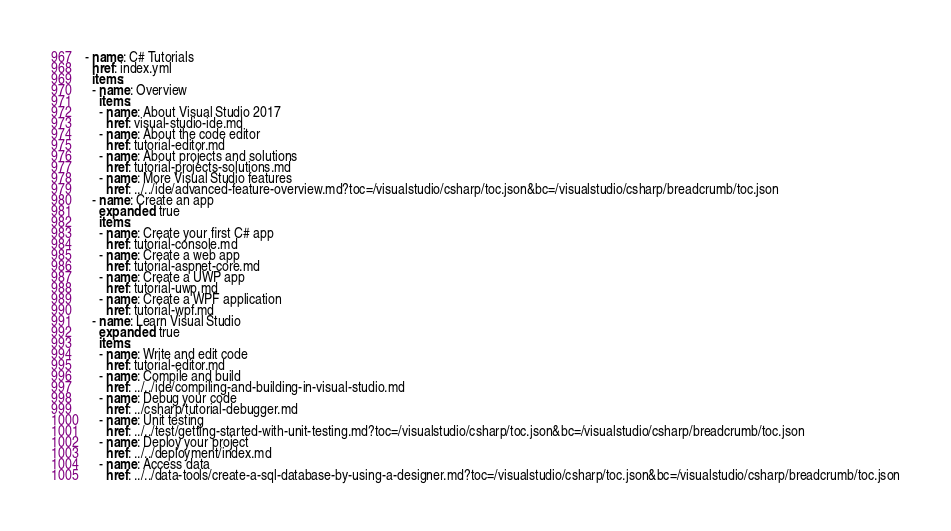Convert code to text. <code><loc_0><loc_0><loc_500><loc_500><_YAML_>- name: C# Tutorials
  href: index.yml
  items:
  - name: Overview
    items:
    - name: About Visual Studio 2017
      href: visual-studio-ide.md
    - name: About the code editor
      href: tutorial-editor.md
    - name: About projects and solutions
      href: tutorial-projects-solutions.md
    - name: More Visual Studio features
      href: ../../ide/advanced-feature-overview.md?toc=/visualstudio/csharp/toc.json&bc=/visualstudio/csharp/breadcrumb/toc.json
  - name: Create an app
    expanded: true
    items:
    - name: Create your first C# app
      href: tutorial-console.md
    - name: Create a web app
      href: tutorial-aspnet-core.md
    - name: Create a UWP app
      href: tutorial-uwp.md
    - name: Create a WPF application
      href: tutorial-wpf.md
  - name: Learn Visual Studio
    expanded: true
    items:
    - name: Write and edit code
      href: tutorial-editor.md
    - name: Compile and build
      href: ../../ide/compiling-and-building-in-visual-studio.md
    - name: Debug your code
      href: ../csharp/tutorial-debugger.md
    - name: Unit testing
      href: ../../test/getting-started-with-unit-testing.md?toc=/visualstudio/csharp/toc.json&bc=/visualstudio/csharp/breadcrumb/toc.json
    - name: Deploy your project
      href: ../../deployment/index.md
    - name: Access data
      href: ../../data-tools/create-a-sql-database-by-using-a-designer.md?toc=/visualstudio/csharp/toc.json&bc=/visualstudio/csharp/breadcrumb/toc.json
</code> 